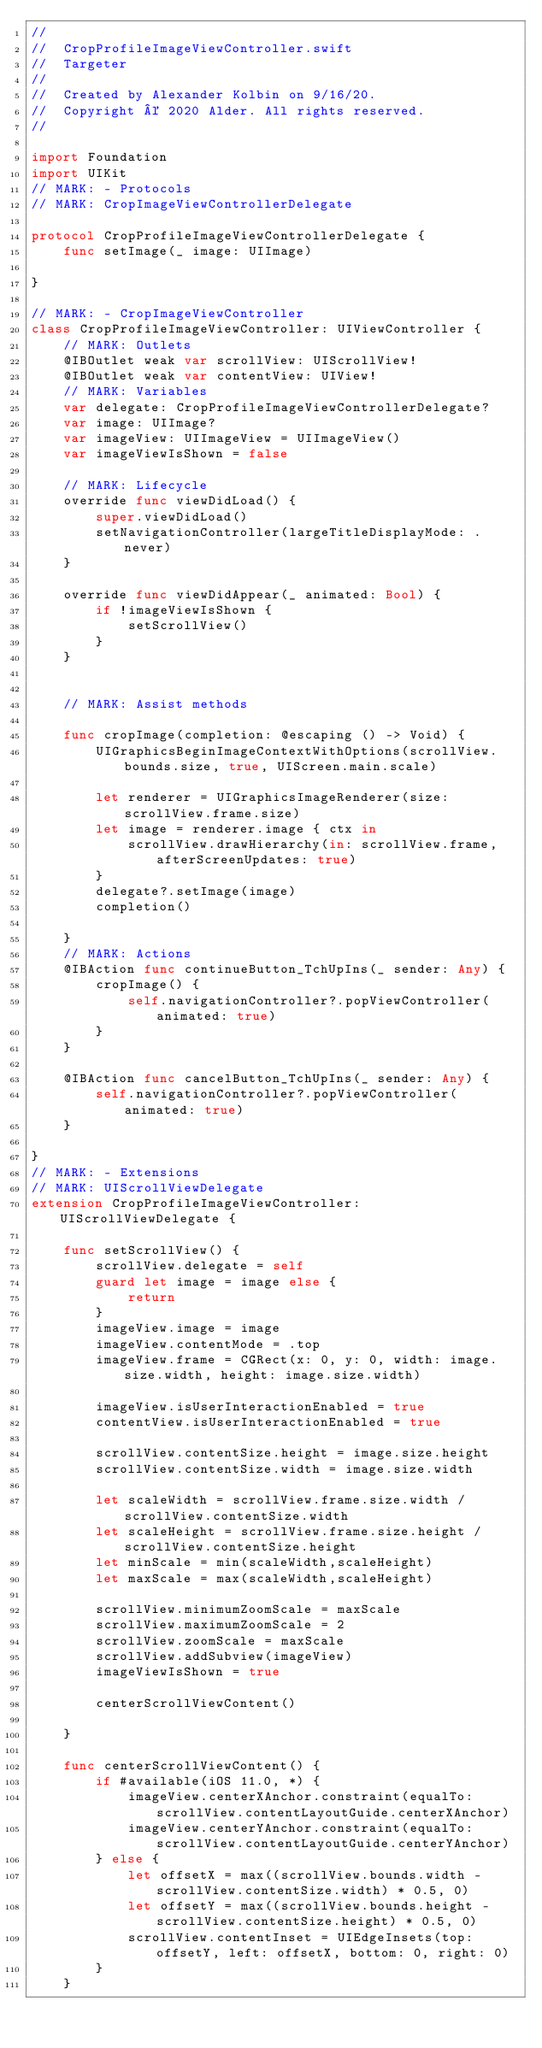Convert code to text. <code><loc_0><loc_0><loc_500><loc_500><_Swift_>//
//  CropProfileImageViewController.swift
//  Targeter
//
//  Created by Alexander Kolbin on 9/16/20.
//  Copyright © 2020 Alder. All rights reserved.
//

import Foundation
import UIKit
// MARK: - Protocols
// MARK: CropImageViewControllerDelegate

protocol CropProfileImageViewControllerDelegate {
    func setImage(_ image: UIImage)
    
}

// MARK: - CropImageViewController
class CropProfileImageViewController: UIViewController {
    // MARK: Outlets
    @IBOutlet weak var scrollView: UIScrollView!
    @IBOutlet weak var contentView: UIView!
    // MARK: Variables
    var delegate: CropProfileImageViewControllerDelegate?
    var image: UIImage?
    var imageView: UIImageView = UIImageView()
    var imageViewIsShown = false

    // MARK: Lifecycle
    override func viewDidLoad() {
        super.viewDidLoad()
        setNavigationController(largeTitleDisplayMode: .never)
    }

    override func viewDidAppear(_ animated: Bool) {
        if !imageViewIsShown {
            setScrollView()
        }
    }
    
    
    // MARK: Assist methods

    func cropImage(completion: @escaping () -> Void) {
        UIGraphicsBeginImageContextWithOptions(scrollView.bounds.size, true, UIScreen.main.scale)

        let renderer = UIGraphicsImageRenderer(size: scrollView.frame.size)
        let image = renderer.image { ctx in
            scrollView.drawHierarchy(in: scrollView.frame, afterScreenUpdates: true)
        }
        delegate?.setImage(image)
        completion()

    }
    // MARK: Actions
    @IBAction func continueButton_TchUpIns(_ sender: Any) {
        cropImage() {
            self.navigationController?.popViewController(animated: true)
        }
    }
    
    @IBAction func cancelButton_TchUpIns(_ sender: Any) {
        self.navigationController?.popViewController(animated: true)
    }
    
}
// MARK: - Extensions
// MARK: UIScrollViewDelegate
extension CropProfileImageViewController: UIScrollViewDelegate {
    
    func setScrollView() {
        scrollView.delegate = self
        guard let image = image else {
            return
        }
        imageView.image = image
        imageView.contentMode = .top
        imageView.frame = CGRect(x: 0, y: 0, width: image.size.width, height: image.size.width)

        imageView.isUserInteractionEnabled = true
        contentView.isUserInteractionEnabled = true
        
        scrollView.contentSize.height = image.size.height
        scrollView.contentSize.width = image.size.width
        
        let scaleWidth = scrollView.frame.size.width / scrollView.contentSize.width
        let scaleHeight = scrollView.frame.size.height / scrollView.contentSize.height
        let minScale = min(scaleWidth,scaleHeight)
        let maxScale = max(scaleWidth,scaleHeight)
        
        scrollView.minimumZoomScale = maxScale
        scrollView.maximumZoomScale = 2
        scrollView.zoomScale = maxScale
        scrollView.addSubview(imageView)
        imageViewIsShown = true
        
        centerScrollViewContent()
      
    }
    
    func centerScrollViewContent() {
        if #available(iOS 11.0, *) {
            imageView.centerXAnchor.constraint(equalTo: scrollView.contentLayoutGuide.centerXAnchor)
            imageView.centerYAnchor.constraint(equalTo: scrollView.contentLayoutGuide.centerYAnchor)
        } else {
            let offsetX = max((scrollView.bounds.width - scrollView.contentSize.width) * 0.5, 0)
            let offsetY = max((scrollView.bounds.height - scrollView.contentSize.height) * 0.5, 0)
            scrollView.contentInset = UIEdgeInsets(top: offsetY, left: offsetX, bottom: 0, right: 0)
        }
    }
    
    </code> 